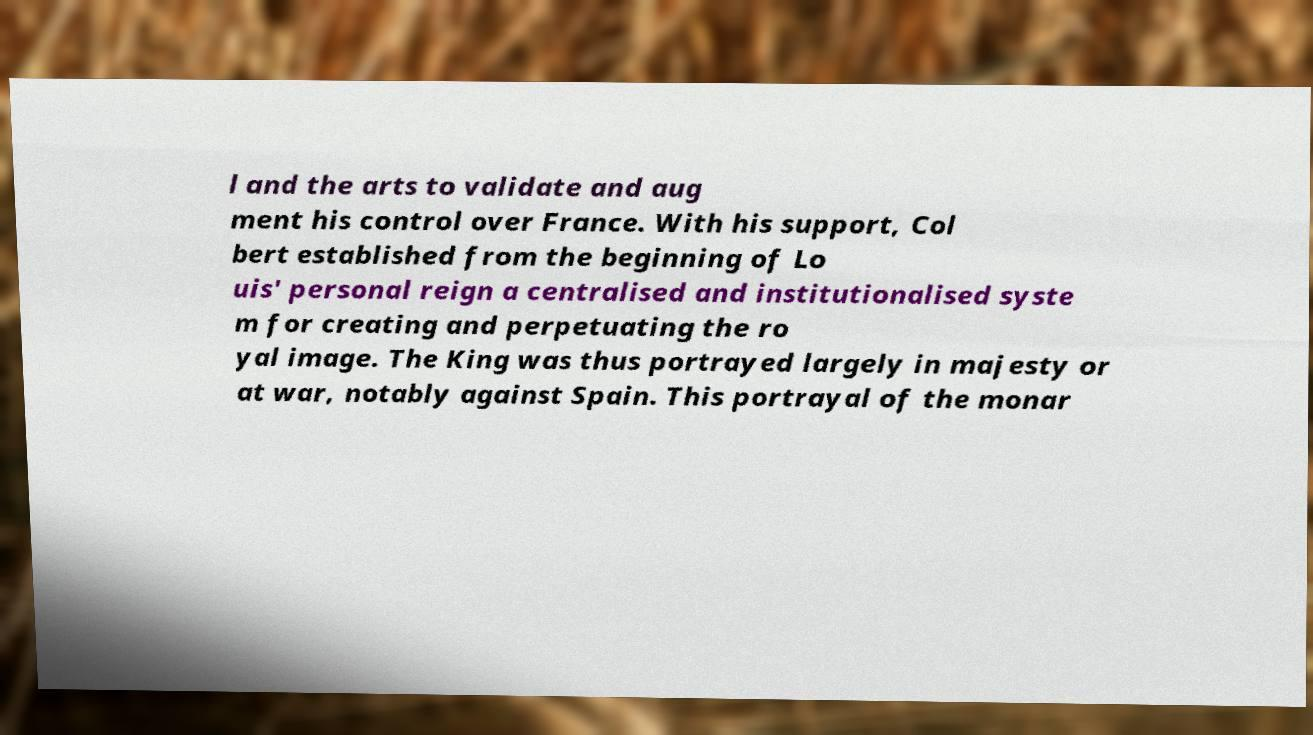Could you extract and type out the text from this image? l and the arts to validate and aug ment his control over France. With his support, Col bert established from the beginning of Lo uis' personal reign a centralised and institutionalised syste m for creating and perpetuating the ro yal image. The King was thus portrayed largely in majesty or at war, notably against Spain. This portrayal of the monar 